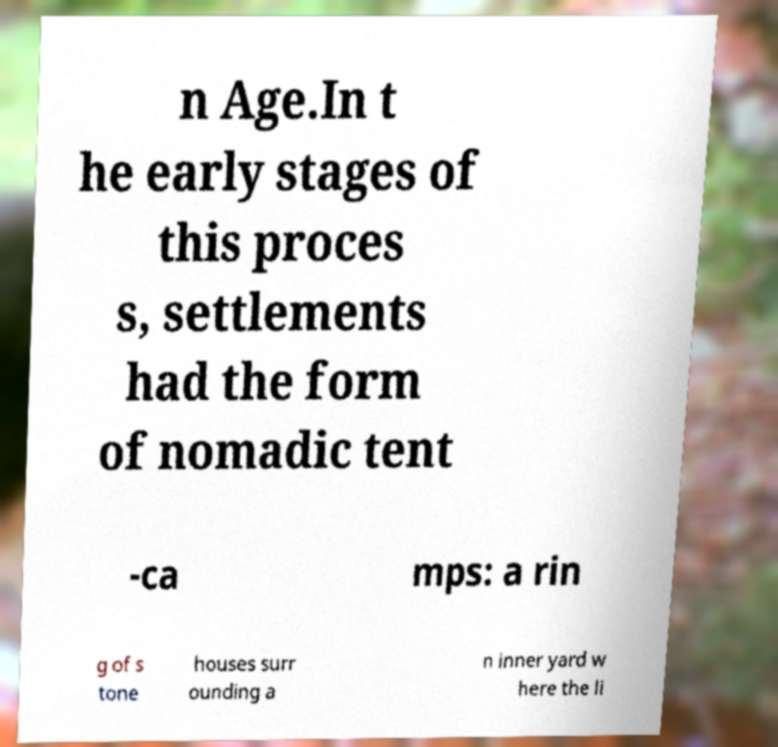For documentation purposes, I need the text within this image transcribed. Could you provide that? n Age.In t he early stages of this proces s, settlements had the form of nomadic tent -ca mps: a rin g of s tone houses surr ounding a n inner yard w here the li 